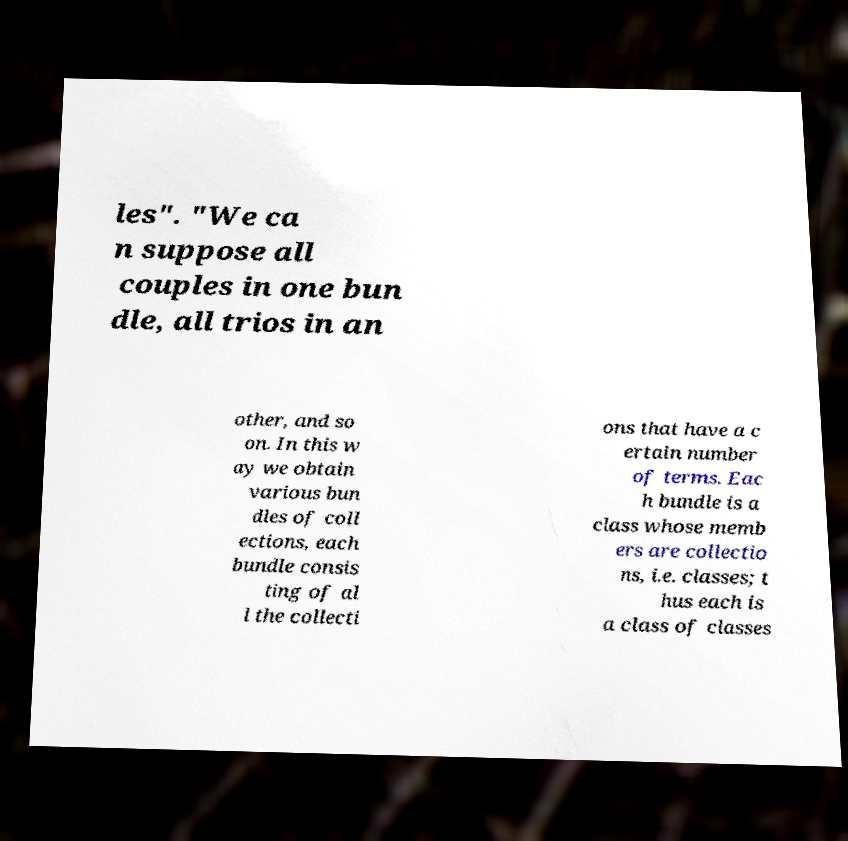For documentation purposes, I need the text within this image transcribed. Could you provide that? les". "We ca n suppose all couples in one bun dle, all trios in an other, and so on. In this w ay we obtain various bun dles of coll ections, each bundle consis ting of al l the collecti ons that have a c ertain number of terms. Eac h bundle is a class whose memb ers are collectio ns, i.e. classes; t hus each is a class of classes 